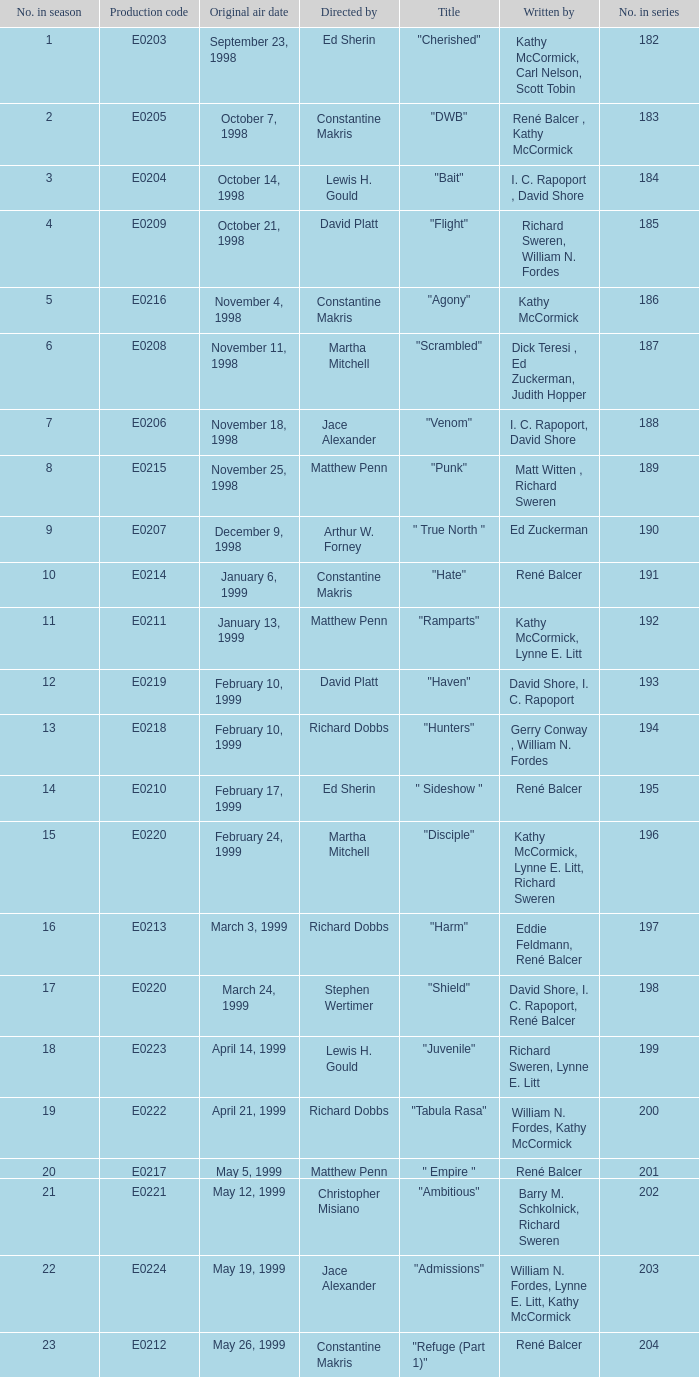What is the season number of the episode written by Matt Witten , Richard Sweren? 8.0. 